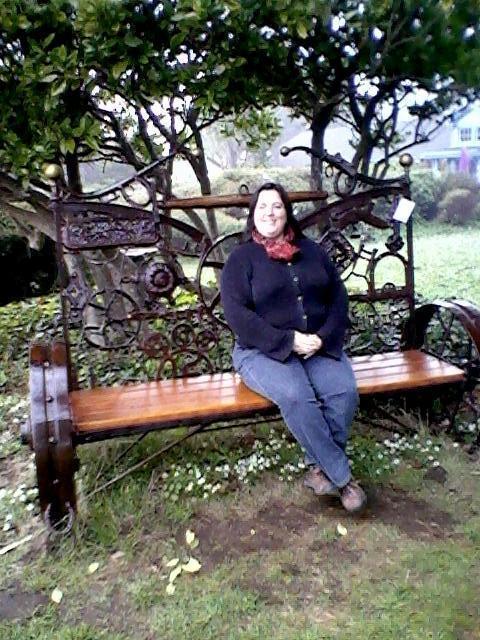How many people are in the photo?
Give a very brief answer. 1. How many benches can be seen?
Give a very brief answer. 1. How many dogs are wearing a leash?
Give a very brief answer. 0. 